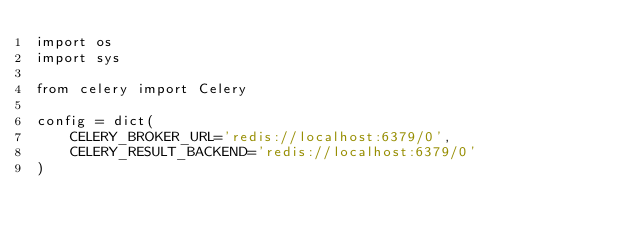<code> <loc_0><loc_0><loc_500><loc_500><_Python_>import os
import sys

from celery import Celery

config = dict(
    CELERY_BROKER_URL='redis://localhost:6379/0',
    CELERY_RESULT_BACKEND='redis://localhost:6379/0'
)
</code> 